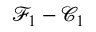<formula> <loc_0><loc_0><loc_500><loc_500>\mathcal { F } _ { 1 } - \mathcal { C } _ { 1 }</formula> 